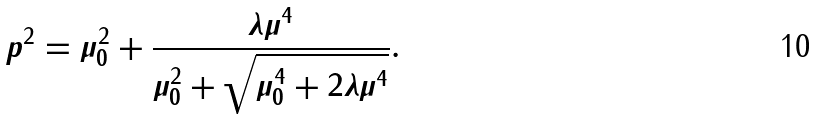Convert formula to latex. <formula><loc_0><loc_0><loc_500><loc_500>p ^ { 2 } = \mu _ { 0 } ^ { 2 } + { \frac { \lambda \mu ^ { 4 } } { \mu _ { 0 } ^ { 2 } + { \sqrt { \mu _ { 0 } ^ { 4 } + 2 \lambda \mu ^ { 4 } } } } } .</formula> 